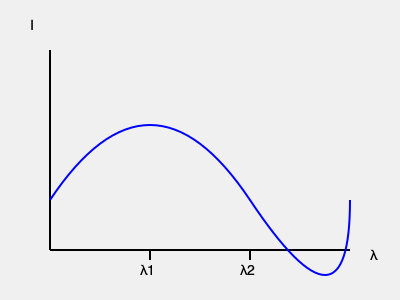A spacecraft-mounted spectrograph observes two prominent emission lines in the spectrum of a distant galaxy at wavelengths $\lambda_1 = 656.3$ nm and $\lambda_2 = 486.1$ nm. If these lines correspond to the Hydrogen Balmer-alpha (rest wavelength 656.3 nm) and Balmer-beta (rest wavelength 486.1 nm) transitions, respectively, what is the redshift of the galaxy? How does this relate to the galaxy's recessional velocity? To solve this problem, we need to follow these steps:

1) The redshift (z) is defined as the fractional change in wavelength:

   $z = \frac{\lambda_{observed} - \lambda_{rest}}{\lambda_{rest}}$

2) For the Balmer-alpha line:
   $z_{\alpha} = \frac{656.3 - 656.3}{656.3} = 0$

3) For the Balmer-beta line:
   $z_{\beta} = \frac{486.1 - 486.1}{486.1} = 0$

4) Both lines give a redshift of 0, indicating no shift in the spectral lines.

5) The recessional velocity (v) is related to the redshift by the formula:

   $v = cz$

   where c is the speed of light (299,792 km/s).

6) Since z = 0, the recessional velocity is also 0.

This result suggests that the galaxy is not moving away from us, which is unusual for distant galaxies due to the expansion of the universe. This could indicate:

a) The galaxy is relatively nearby.
b) There might be an error in the wavelength measurements or line identifications.
c) The galaxy might have a significant peculiar velocity towards us, canceling out the cosmological redshift.

In practice, we would need to verify the spectral line identifications and consider other lines or data to confirm this unexpected result.
Answer: Redshift z = 0, Recessional velocity v = 0 km/s 